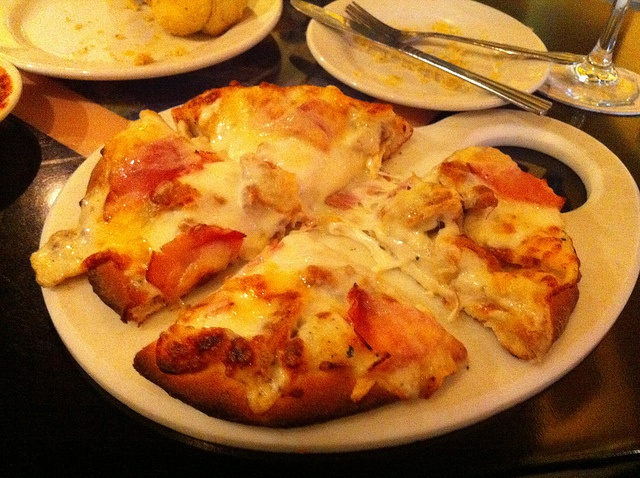Describe the objects in this image and their specific colors. I can see pizza in tan, orange, red, and brown tones, wine glass in tan, olive, and orange tones, knife in tan, olive, maroon, and gray tones, and fork in tan, olive, and maroon tones in this image. 